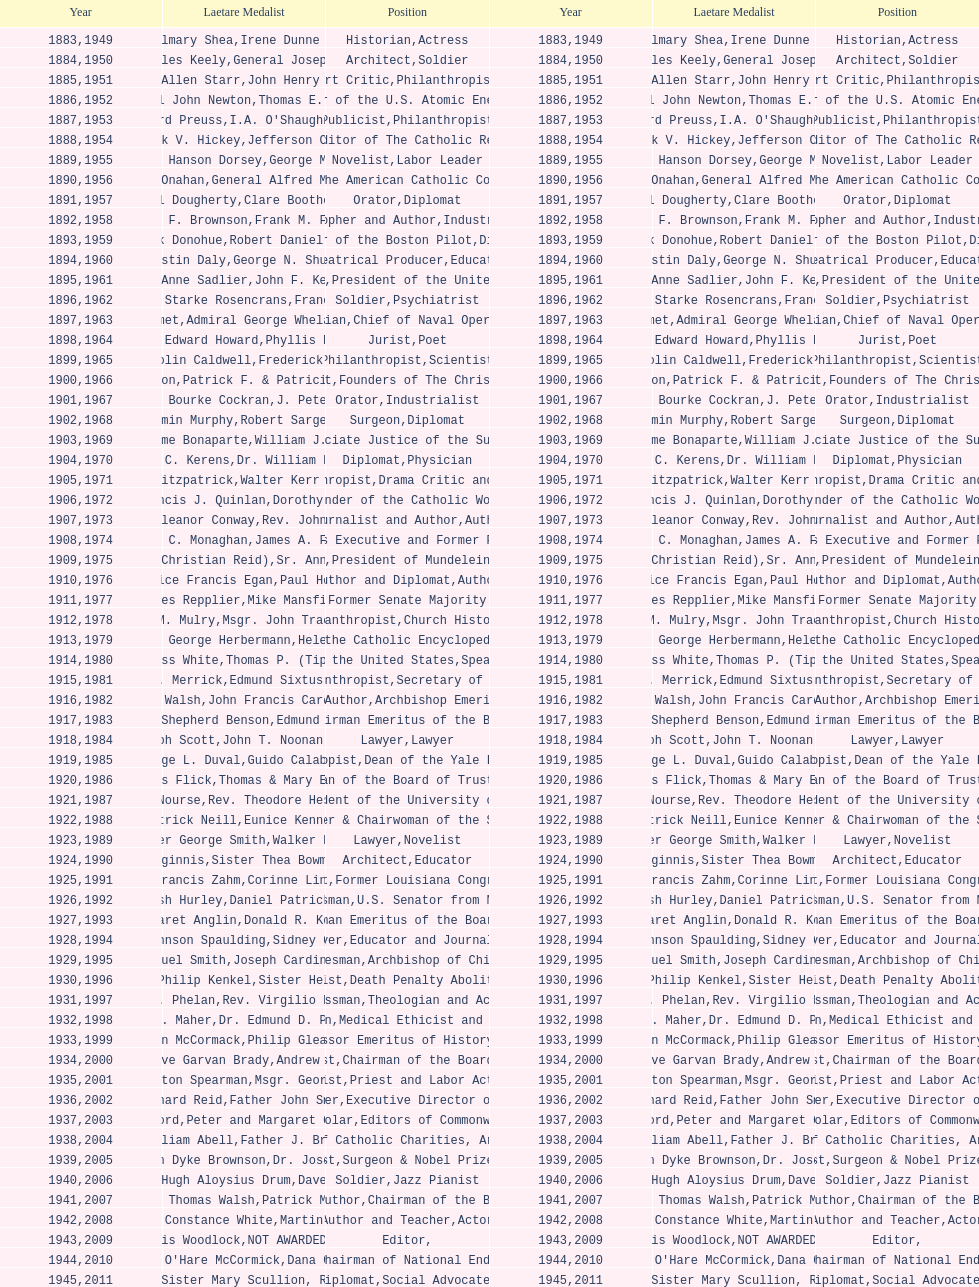What is the name of the laetare medalist listed before edward preuss? General John Newton. 